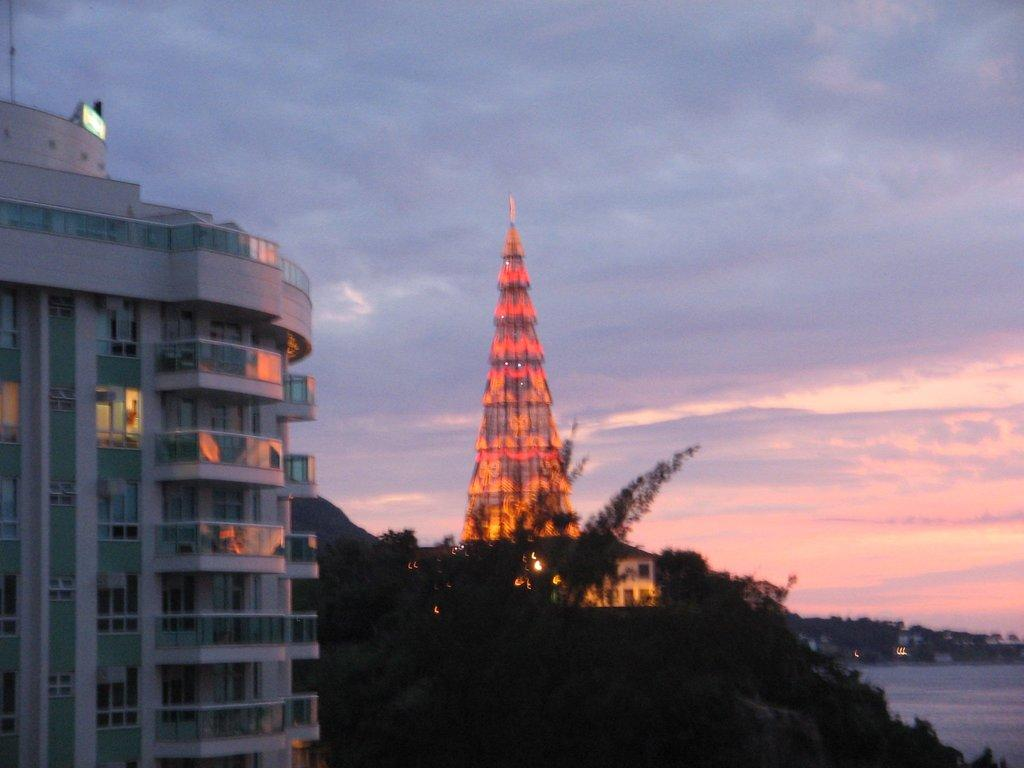What is the main structure in the front of the image? There is a building in the front of the image. What can be seen in the center of the image? There are trees in the center of the image. What is located in the background of the image? There is a tower and trees in the background of the image. What else can be seen in the background of the image? There is water visible in the background of the image. How would you describe the sky in the image? The sky is cloudy in the image. What type of songs can be heard coming from the building in the image? There is no indication in the image that any songs are being played or heard from the building. What scientific discoveries are being made in the image? There is no information in the image to suggest that any scientific discoveries are being made. 